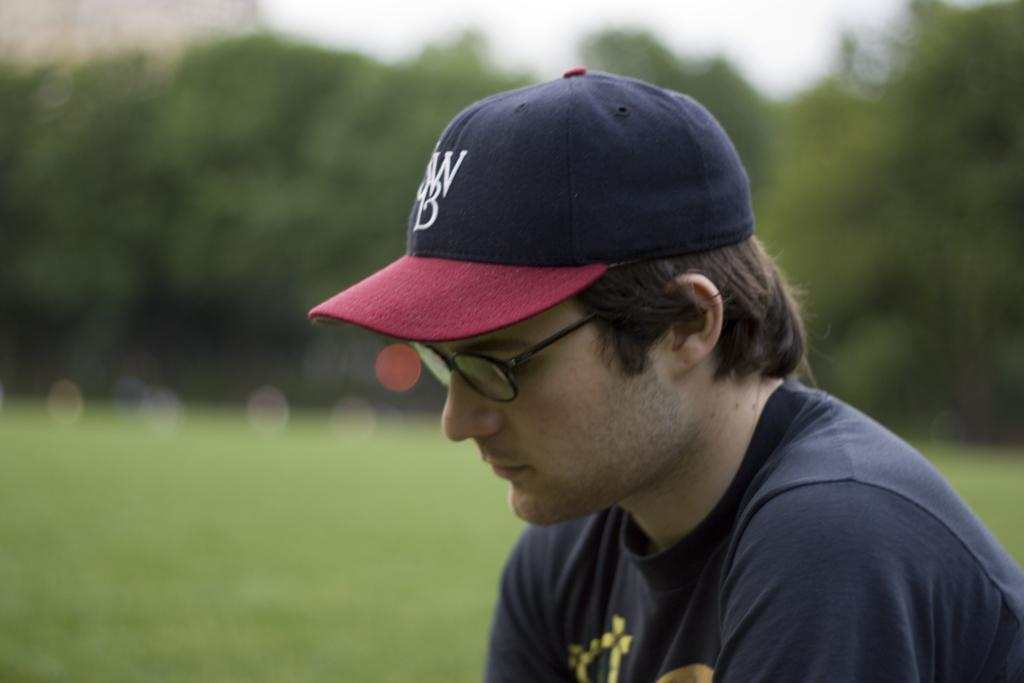Who is present in the image? There is a man in the image. What is the man wearing on his face? The man is wearing glasses. What is the man wearing on his head? The man is wearing a cap. What is the man wearing on his upper body? The man is wearing a t-shirt. What can be seen in the background of the image? The background of the image includes trees. What is visible beneath the man's feet? The ground is visible in the image. What type of shock can be seen affecting the man in the image? There is no shock present in the image; the man appears to be standing still and wearing normal clothing. 